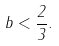Convert formula to latex. <formula><loc_0><loc_0><loc_500><loc_500>b < \frac { 2 } { 3 } .</formula> 